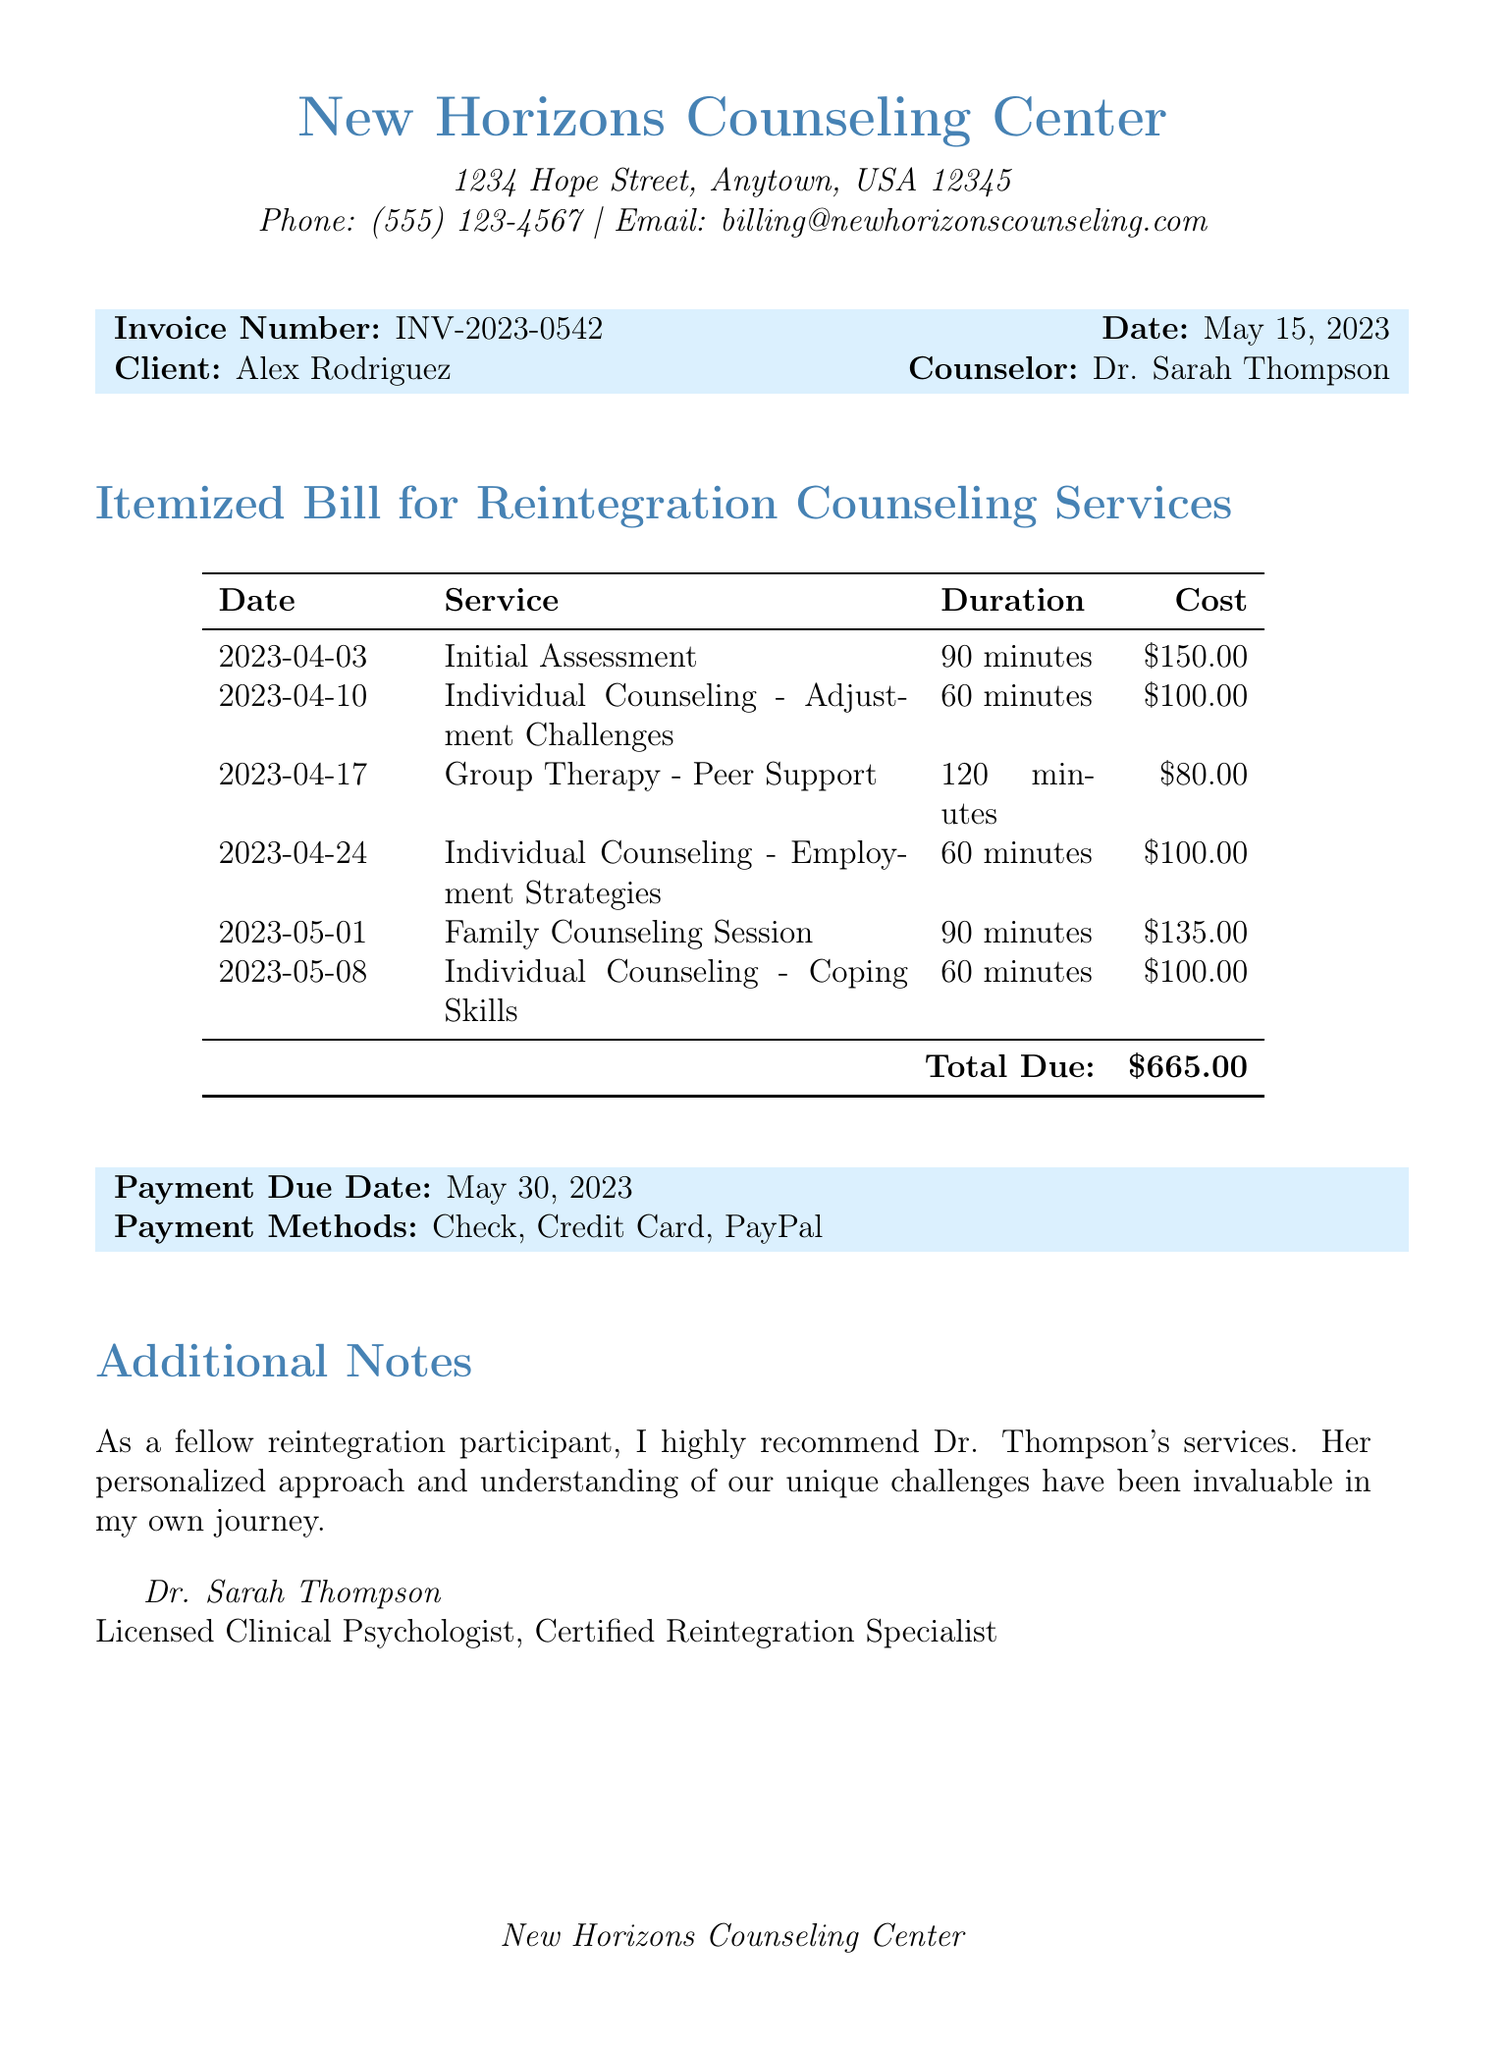What is the invoice number? The invoice number is a unique identifier for the billing document which is listed in the document.
Answer: INV-2023-0542 What is the total cost of services? The total cost is the sum of all itemized services provided in the invoice, which is clearly stated.
Answer: $665.00 Who is the counselor? The counselor's name is provided in the invoice along with their credentials.
Answer: Dr. Sarah Thompson What is the payment due date? The payment due date is specified in the invoice as the last date to make the payment.
Answer: May 30, 2023 How many sessions were billed? This question asks for the count of services listed in the document based on the itemized bill.
Answer: 6 What type of service was provided on April 17, 2023? This question refers to a specific entry in the itemized bill for that date.
Answer: Group Therapy - Peer Support What is the duration of the initial assessment? The duration is clearly listed beside the service for that date.
Answer: 90 minutes What payment methods are accepted? This question is based on the information regarding payment options listed in the document.
Answer: Check, Credit Card, PayPal What is the email address for billing inquiries? The email address is provided in the document for any billing-related questions.
Answer: billing@newhorizonscounseling.com 